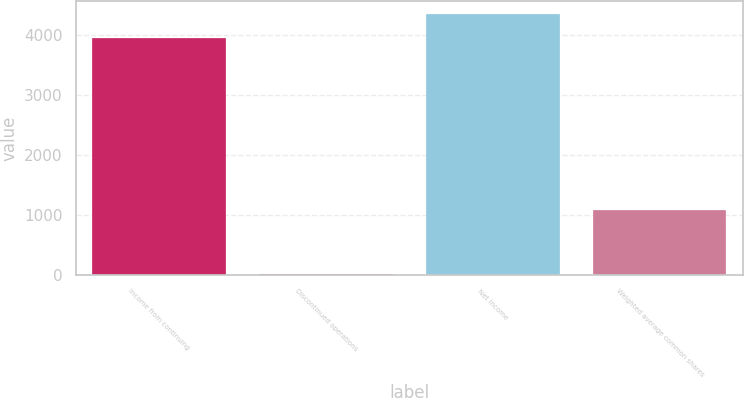<chart> <loc_0><loc_0><loc_500><loc_500><bar_chart><fcel>Income from continuing<fcel>Discontinued operations<fcel>Net income<fcel>Weighted average common shares<nl><fcel>3948<fcel>8<fcel>4342.8<fcel>1084.8<nl></chart> 